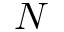Convert formula to latex. <formula><loc_0><loc_0><loc_500><loc_500>N</formula> 